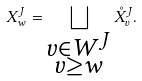Convert formula to latex. <formula><loc_0><loc_0><loc_500><loc_500>X _ { w } ^ { J } = \bigsqcup _ { \substack { v \in W ^ { J } \\ v \geq w } } \mathring { X } ^ { J } _ { v } .</formula> 